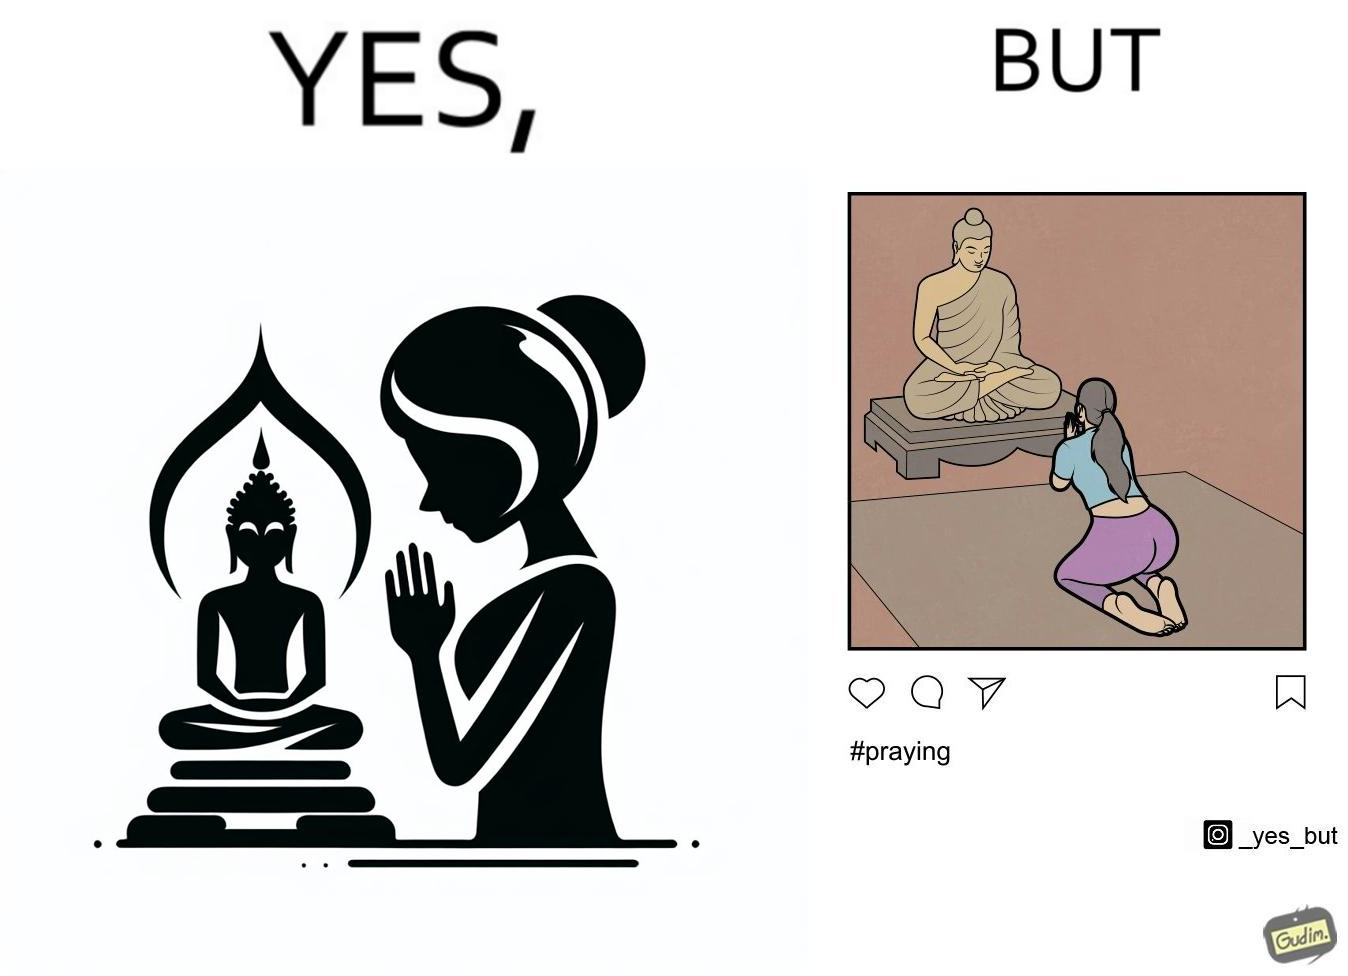Describe what you see in the left and right parts of this image. In the left part of the image: a woman is seen praying before the Buddha  statue with closed hands In the right part of the image: a photo of a woman, praying before the Buddha  statue with closed hands, posted on some social media  with hashtags 